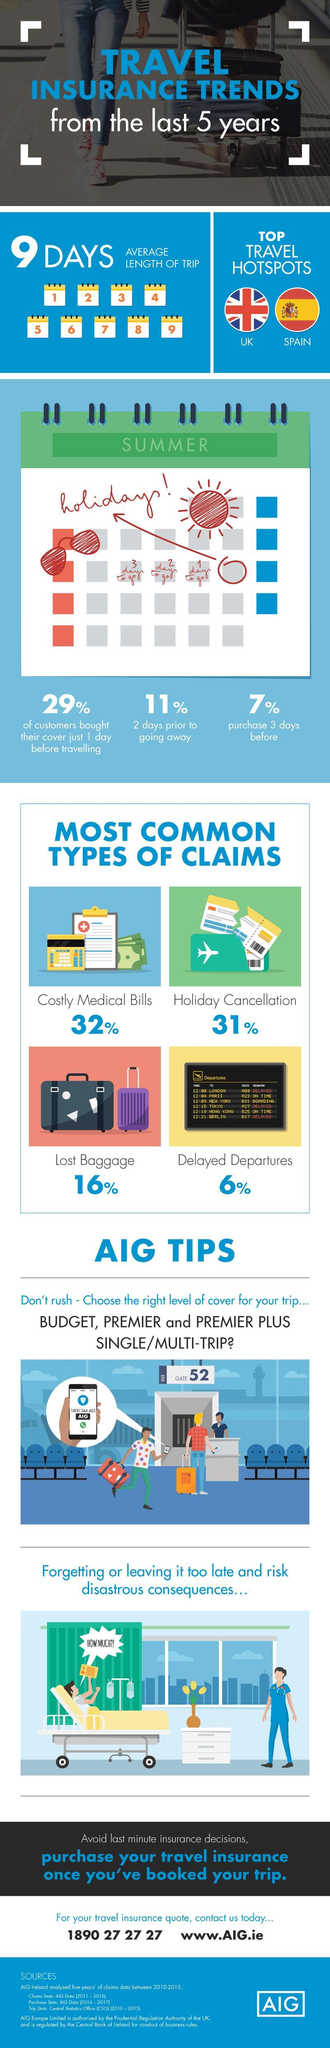What is written on the green portion of the calendar?
Answer the question with a short phrase. summer What is the customer care number for AIG written on the mobile screen? 1800 344 455 What percentage of travelers buy insurance three days before their date of travel, 29%, 11%, or 7%? 7% What is the name of the travel insurance company written on the smart phone? AIG Which the second most common type of travel insurance claim ? Holiday Cancellation What percentage of insurance claims are due to delayed departures, 16%, 6%, or 31%? 6% How many countries are mentioned as the sought after destinations for travel? 2 